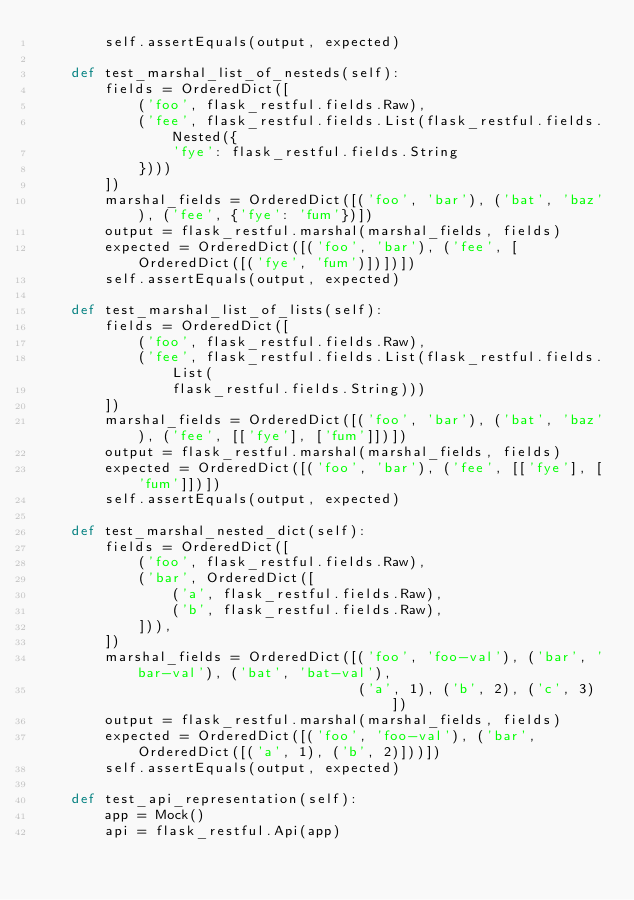Convert code to text. <code><loc_0><loc_0><loc_500><loc_500><_Python_>        self.assertEquals(output, expected)

    def test_marshal_list_of_nesteds(self):
        fields = OrderedDict([
            ('foo', flask_restful.fields.Raw),
            ('fee', flask_restful.fields.List(flask_restful.fields.Nested({
                'fye': flask_restful.fields.String
            })))
        ])
        marshal_fields = OrderedDict([('foo', 'bar'), ('bat', 'baz'), ('fee', {'fye': 'fum'})])
        output = flask_restful.marshal(marshal_fields, fields)
        expected = OrderedDict([('foo', 'bar'), ('fee', [OrderedDict([('fye', 'fum')])])])
        self.assertEquals(output, expected)

    def test_marshal_list_of_lists(self):
        fields = OrderedDict([
            ('foo', flask_restful.fields.Raw),
            ('fee', flask_restful.fields.List(flask_restful.fields.List(
                flask_restful.fields.String)))
        ])
        marshal_fields = OrderedDict([('foo', 'bar'), ('bat', 'baz'), ('fee', [['fye'], ['fum']])])
        output = flask_restful.marshal(marshal_fields, fields)
        expected = OrderedDict([('foo', 'bar'), ('fee', [['fye'], ['fum']])])
        self.assertEquals(output, expected)

    def test_marshal_nested_dict(self):
        fields = OrderedDict([
            ('foo', flask_restful.fields.Raw),
            ('bar', OrderedDict([
                ('a', flask_restful.fields.Raw),
                ('b', flask_restful.fields.Raw),
            ])),
        ])
        marshal_fields = OrderedDict([('foo', 'foo-val'), ('bar', 'bar-val'), ('bat', 'bat-val'),
                                      ('a', 1), ('b', 2), ('c', 3)])
        output = flask_restful.marshal(marshal_fields, fields)
        expected = OrderedDict([('foo', 'foo-val'), ('bar', OrderedDict([('a', 1), ('b', 2)]))])
        self.assertEquals(output, expected)

    def test_api_representation(self):
        app = Mock()
        api = flask_restful.Api(app)
</code> 